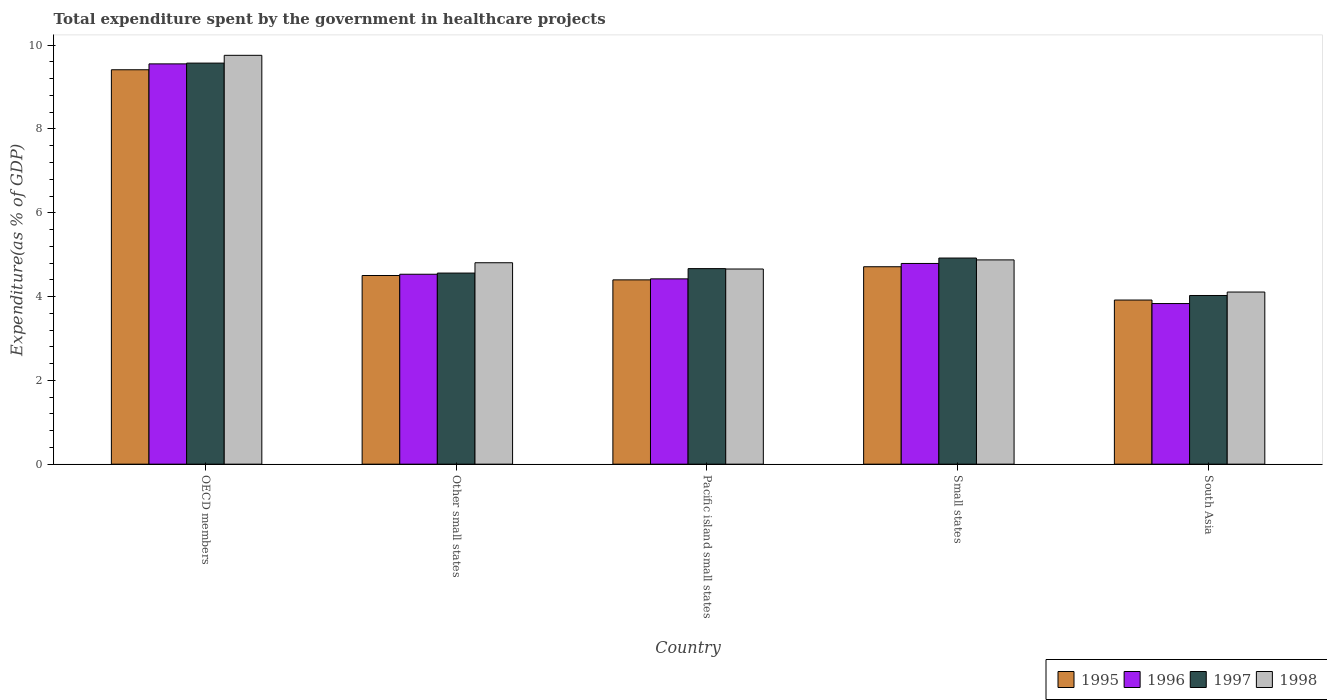How many different coloured bars are there?
Offer a very short reply. 4. How many groups of bars are there?
Your answer should be compact. 5. Are the number of bars on each tick of the X-axis equal?
Your answer should be very brief. Yes. How many bars are there on the 5th tick from the right?
Offer a very short reply. 4. What is the label of the 4th group of bars from the left?
Your answer should be compact. Small states. In how many cases, is the number of bars for a given country not equal to the number of legend labels?
Ensure brevity in your answer.  0. What is the total expenditure spent by the government in healthcare projects in 1998 in Pacific island small states?
Keep it short and to the point. 4.66. Across all countries, what is the maximum total expenditure spent by the government in healthcare projects in 1995?
Provide a succinct answer. 9.41. Across all countries, what is the minimum total expenditure spent by the government in healthcare projects in 1995?
Offer a very short reply. 3.92. In which country was the total expenditure spent by the government in healthcare projects in 1995 maximum?
Offer a terse response. OECD members. What is the total total expenditure spent by the government in healthcare projects in 1998 in the graph?
Offer a very short reply. 28.21. What is the difference between the total expenditure spent by the government in healthcare projects in 1996 in Other small states and that in Pacific island small states?
Provide a succinct answer. 0.11. What is the difference between the total expenditure spent by the government in healthcare projects in 1996 in Other small states and the total expenditure spent by the government in healthcare projects in 1998 in OECD members?
Offer a terse response. -5.23. What is the average total expenditure spent by the government in healthcare projects in 1997 per country?
Offer a very short reply. 5.55. What is the difference between the total expenditure spent by the government in healthcare projects of/in 1997 and total expenditure spent by the government in healthcare projects of/in 1995 in South Asia?
Your response must be concise. 0.11. In how many countries, is the total expenditure spent by the government in healthcare projects in 1996 greater than 1.6 %?
Give a very brief answer. 5. What is the ratio of the total expenditure spent by the government in healthcare projects in 1997 in Pacific island small states to that in South Asia?
Your answer should be very brief. 1.16. What is the difference between the highest and the second highest total expenditure spent by the government in healthcare projects in 1998?
Provide a short and direct response. 4.88. What is the difference between the highest and the lowest total expenditure spent by the government in healthcare projects in 1996?
Ensure brevity in your answer.  5.72. Is the sum of the total expenditure spent by the government in healthcare projects in 1996 in OECD members and South Asia greater than the maximum total expenditure spent by the government in healthcare projects in 1995 across all countries?
Your answer should be very brief. Yes. Is it the case that in every country, the sum of the total expenditure spent by the government in healthcare projects in 1996 and total expenditure spent by the government in healthcare projects in 1997 is greater than the sum of total expenditure spent by the government in healthcare projects in 1998 and total expenditure spent by the government in healthcare projects in 1995?
Your response must be concise. No. What does the 4th bar from the left in Other small states represents?
Give a very brief answer. 1998. What does the 2nd bar from the right in OECD members represents?
Make the answer very short. 1997. How many bars are there?
Keep it short and to the point. 20. Are all the bars in the graph horizontal?
Your answer should be very brief. No. Does the graph contain grids?
Your answer should be very brief. No. How many legend labels are there?
Provide a succinct answer. 4. What is the title of the graph?
Your response must be concise. Total expenditure spent by the government in healthcare projects. Does "1971" appear as one of the legend labels in the graph?
Your answer should be very brief. No. What is the label or title of the Y-axis?
Offer a very short reply. Expenditure(as % of GDP). What is the Expenditure(as % of GDP) of 1995 in OECD members?
Your answer should be very brief. 9.41. What is the Expenditure(as % of GDP) in 1996 in OECD members?
Provide a succinct answer. 9.55. What is the Expenditure(as % of GDP) in 1997 in OECD members?
Provide a short and direct response. 9.57. What is the Expenditure(as % of GDP) in 1998 in OECD members?
Provide a succinct answer. 9.76. What is the Expenditure(as % of GDP) in 1995 in Other small states?
Offer a terse response. 4.5. What is the Expenditure(as % of GDP) of 1996 in Other small states?
Keep it short and to the point. 4.53. What is the Expenditure(as % of GDP) in 1997 in Other small states?
Offer a very short reply. 4.56. What is the Expenditure(as % of GDP) of 1998 in Other small states?
Ensure brevity in your answer.  4.81. What is the Expenditure(as % of GDP) of 1995 in Pacific island small states?
Give a very brief answer. 4.4. What is the Expenditure(as % of GDP) of 1996 in Pacific island small states?
Offer a very short reply. 4.42. What is the Expenditure(as % of GDP) in 1997 in Pacific island small states?
Your answer should be compact. 4.67. What is the Expenditure(as % of GDP) of 1998 in Pacific island small states?
Provide a short and direct response. 4.66. What is the Expenditure(as % of GDP) in 1995 in Small states?
Provide a succinct answer. 4.71. What is the Expenditure(as % of GDP) of 1996 in Small states?
Your response must be concise. 4.79. What is the Expenditure(as % of GDP) in 1997 in Small states?
Your answer should be very brief. 4.92. What is the Expenditure(as % of GDP) in 1998 in Small states?
Offer a terse response. 4.88. What is the Expenditure(as % of GDP) in 1995 in South Asia?
Provide a succinct answer. 3.92. What is the Expenditure(as % of GDP) of 1996 in South Asia?
Make the answer very short. 3.83. What is the Expenditure(as % of GDP) in 1997 in South Asia?
Give a very brief answer. 4.03. What is the Expenditure(as % of GDP) of 1998 in South Asia?
Ensure brevity in your answer.  4.11. Across all countries, what is the maximum Expenditure(as % of GDP) in 1995?
Offer a terse response. 9.41. Across all countries, what is the maximum Expenditure(as % of GDP) in 1996?
Offer a very short reply. 9.55. Across all countries, what is the maximum Expenditure(as % of GDP) of 1997?
Keep it short and to the point. 9.57. Across all countries, what is the maximum Expenditure(as % of GDP) in 1998?
Offer a terse response. 9.76. Across all countries, what is the minimum Expenditure(as % of GDP) in 1995?
Give a very brief answer. 3.92. Across all countries, what is the minimum Expenditure(as % of GDP) of 1996?
Give a very brief answer. 3.83. Across all countries, what is the minimum Expenditure(as % of GDP) in 1997?
Ensure brevity in your answer.  4.03. Across all countries, what is the minimum Expenditure(as % of GDP) in 1998?
Ensure brevity in your answer.  4.11. What is the total Expenditure(as % of GDP) of 1995 in the graph?
Offer a very short reply. 26.94. What is the total Expenditure(as % of GDP) in 1996 in the graph?
Your answer should be compact. 27.13. What is the total Expenditure(as % of GDP) of 1997 in the graph?
Provide a succinct answer. 27.75. What is the total Expenditure(as % of GDP) in 1998 in the graph?
Offer a very short reply. 28.21. What is the difference between the Expenditure(as % of GDP) of 1995 in OECD members and that in Other small states?
Make the answer very short. 4.91. What is the difference between the Expenditure(as % of GDP) in 1996 in OECD members and that in Other small states?
Your response must be concise. 5.02. What is the difference between the Expenditure(as % of GDP) of 1997 in OECD members and that in Other small states?
Give a very brief answer. 5.01. What is the difference between the Expenditure(as % of GDP) of 1998 in OECD members and that in Other small states?
Your answer should be very brief. 4.95. What is the difference between the Expenditure(as % of GDP) of 1995 in OECD members and that in Pacific island small states?
Ensure brevity in your answer.  5.01. What is the difference between the Expenditure(as % of GDP) in 1996 in OECD members and that in Pacific island small states?
Make the answer very short. 5.13. What is the difference between the Expenditure(as % of GDP) of 1997 in OECD members and that in Pacific island small states?
Provide a short and direct response. 4.91. What is the difference between the Expenditure(as % of GDP) of 1998 in OECD members and that in Pacific island small states?
Offer a terse response. 5.1. What is the difference between the Expenditure(as % of GDP) of 1995 in OECD members and that in Small states?
Provide a succinct answer. 4.7. What is the difference between the Expenditure(as % of GDP) of 1996 in OECD members and that in Small states?
Your response must be concise. 4.76. What is the difference between the Expenditure(as % of GDP) in 1997 in OECD members and that in Small states?
Your answer should be compact. 4.65. What is the difference between the Expenditure(as % of GDP) in 1998 in OECD members and that in Small states?
Give a very brief answer. 4.88. What is the difference between the Expenditure(as % of GDP) of 1995 in OECD members and that in South Asia?
Your answer should be very brief. 5.5. What is the difference between the Expenditure(as % of GDP) in 1996 in OECD members and that in South Asia?
Provide a succinct answer. 5.72. What is the difference between the Expenditure(as % of GDP) in 1997 in OECD members and that in South Asia?
Offer a terse response. 5.55. What is the difference between the Expenditure(as % of GDP) of 1998 in OECD members and that in South Asia?
Give a very brief answer. 5.65. What is the difference between the Expenditure(as % of GDP) in 1995 in Other small states and that in Pacific island small states?
Your response must be concise. 0.1. What is the difference between the Expenditure(as % of GDP) in 1996 in Other small states and that in Pacific island small states?
Give a very brief answer. 0.11. What is the difference between the Expenditure(as % of GDP) of 1997 in Other small states and that in Pacific island small states?
Provide a succinct answer. -0.11. What is the difference between the Expenditure(as % of GDP) of 1998 in Other small states and that in Pacific island small states?
Give a very brief answer. 0.15. What is the difference between the Expenditure(as % of GDP) in 1995 in Other small states and that in Small states?
Provide a short and direct response. -0.21. What is the difference between the Expenditure(as % of GDP) of 1996 in Other small states and that in Small states?
Offer a very short reply. -0.26. What is the difference between the Expenditure(as % of GDP) of 1997 in Other small states and that in Small states?
Provide a succinct answer. -0.36. What is the difference between the Expenditure(as % of GDP) of 1998 in Other small states and that in Small states?
Keep it short and to the point. -0.07. What is the difference between the Expenditure(as % of GDP) in 1995 in Other small states and that in South Asia?
Offer a terse response. 0.59. What is the difference between the Expenditure(as % of GDP) of 1996 in Other small states and that in South Asia?
Give a very brief answer. 0.7. What is the difference between the Expenditure(as % of GDP) in 1997 in Other small states and that in South Asia?
Keep it short and to the point. 0.54. What is the difference between the Expenditure(as % of GDP) of 1998 in Other small states and that in South Asia?
Give a very brief answer. 0.7. What is the difference between the Expenditure(as % of GDP) in 1995 in Pacific island small states and that in Small states?
Give a very brief answer. -0.31. What is the difference between the Expenditure(as % of GDP) of 1996 in Pacific island small states and that in Small states?
Your answer should be very brief. -0.37. What is the difference between the Expenditure(as % of GDP) in 1997 in Pacific island small states and that in Small states?
Your answer should be compact. -0.25. What is the difference between the Expenditure(as % of GDP) of 1998 in Pacific island small states and that in Small states?
Your answer should be compact. -0.22. What is the difference between the Expenditure(as % of GDP) of 1995 in Pacific island small states and that in South Asia?
Provide a succinct answer. 0.48. What is the difference between the Expenditure(as % of GDP) of 1996 in Pacific island small states and that in South Asia?
Provide a succinct answer. 0.59. What is the difference between the Expenditure(as % of GDP) in 1997 in Pacific island small states and that in South Asia?
Give a very brief answer. 0.64. What is the difference between the Expenditure(as % of GDP) in 1998 in Pacific island small states and that in South Asia?
Provide a succinct answer. 0.55. What is the difference between the Expenditure(as % of GDP) of 1995 in Small states and that in South Asia?
Offer a very short reply. 0.79. What is the difference between the Expenditure(as % of GDP) of 1997 in Small states and that in South Asia?
Your answer should be compact. 0.89. What is the difference between the Expenditure(as % of GDP) in 1998 in Small states and that in South Asia?
Your answer should be compact. 0.77. What is the difference between the Expenditure(as % of GDP) of 1995 in OECD members and the Expenditure(as % of GDP) of 1996 in Other small states?
Offer a terse response. 4.88. What is the difference between the Expenditure(as % of GDP) of 1995 in OECD members and the Expenditure(as % of GDP) of 1997 in Other small states?
Offer a very short reply. 4.85. What is the difference between the Expenditure(as % of GDP) of 1995 in OECD members and the Expenditure(as % of GDP) of 1998 in Other small states?
Your answer should be very brief. 4.61. What is the difference between the Expenditure(as % of GDP) of 1996 in OECD members and the Expenditure(as % of GDP) of 1997 in Other small states?
Your answer should be very brief. 4.99. What is the difference between the Expenditure(as % of GDP) of 1996 in OECD members and the Expenditure(as % of GDP) of 1998 in Other small states?
Your answer should be compact. 4.75. What is the difference between the Expenditure(as % of GDP) of 1997 in OECD members and the Expenditure(as % of GDP) of 1998 in Other small states?
Ensure brevity in your answer.  4.77. What is the difference between the Expenditure(as % of GDP) in 1995 in OECD members and the Expenditure(as % of GDP) in 1996 in Pacific island small states?
Your response must be concise. 4.99. What is the difference between the Expenditure(as % of GDP) in 1995 in OECD members and the Expenditure(as % of GDP) in 1997 in Pacific island small states?
Offer a very short reply. 4.75. What is the difference between the Expenditure(as % of GDP) of 1995 in OECD members and the Expenditure(as % of GDP) of 1998 in Pacific island small states?
Your answer should be very brief. 4.76. What is the difference between the Expenditure(as % of GDP) in 1996 in OECD members and the Expenditure(as % of GDP) in 1997 in Pacific island small states?
Your response must be concise. 4.89. What is the difference between the Expenditure(as % of GDP) in 1996 in OECD members and the Expenditure(as % of GDP) in 1998 in Pacific island small states?
Your response must be concise. 4.9. What is the difference between the Expenditure(as % of GDP) of 1997 in OECD members and the Expenditure(as % of GDP) of 1998 in Pacific island small states?
Provide a succinct answer. 4.91. What is the difference between the Expenditure(as % of GDP) in 1995 in OECD members and the Expenditure(as % of GDP) in 1996 in Small states?
Keep it short and to the point. 4.62. What is the difference between the Expenditure(as % of GDP) in 1995 in OECD members and the Expenditure(as % of GDP) in 1997 in Small states?
Provide a succinct answer. 4.49. What is the difference between the Expenditure(as % of GDP) in 1995 in OECD members and the Expenditure(as % of GDP) in 1998 in Small states?
Give a very brief answer. 4.54. What is the difference between the Expenditure(as % of GDP) in 1996 in OECD members and the Expenditure(as % of GDP) in 1997 in Small states?
Provide a succinct answer. 4.63. What is the difference between the Expenditure(as % of GDP) of 1996 in OECD members and the Expenditure(as % of GDP) of 1998 in Small states?
Your answer should be compact. 4.68. What is the difference between the Expenditure(as % of GDP) of 1997 in OECD members and the Expenditure(as % of GDP) of 1998 in Small states?
Keep it short and to the point. 4.7. What is the difference between the Expenditure(as % of GDP) in 1995 in OECD members and the Expenditure(as % of GDP) in 1996 in South Asia?
Your response must be concise. 5.58. What is the difference between the Expenditure(as % of GDP) of 1995 in OECD members and the Expenditure(as % of GDP) of 1997 in South Asia?
Your answer should be compact. 5.39. What is the difference between the Expenditure(as % of GDP) in 1995 in OECD members and the Expenditure(as % of GDP) in 1998 in South Asia?
Offer a very short reply. 5.31. What is the difference between the Expenditure(as % of GDP) in 1996 in OECD members and the Expenditure(as % of GDP) in 1997 in South Asia?
Ensure brevity in your answer.  5.53. What is the difference between the Expenditure(as % of GDP) of 1996 in OECD members and the Expenditure(as % of GDP) of 1998 in South Asia?
Your response must be concise. 5.45. What is the difference between the Expenditure(as % of GDP) in 1997 in OECD members and the Expenditure(as % of GDP) in 1998 in South Asia?
Your answer should be compact. 5.46. What is the difference between the Expenditure(as % of GDP) of 1995 in Other small states and the Expenditure(as % of GDP) of 1996 in Pacific island small states?
Your answer should be very brief. 0.08. What is the difference between the Expenditure(as % of GDP) of 1995 in Other small states and the Expenditure(as % of GDP) of 1997 in Pacific island small states?
Your answer should be very brief. -0.16. What is the difference between the Expenditure(as % of GDP) of 1995 in Other small states and the Expenditure(as % of GDP) of 1998 in Pacific island small states?
Your answer should be compact. -0.16. What is the difference between the Expenditure(as % of GDP) in 1996 in Other small states and the Expenditure(as % of GDP) in 1997 in Pacific island small states?
Ensure brevity in your answer.  -0.13. What is the difference between the Expenditure(as % of GDP) in 1996 in Other small states and the Expenditure(as % of GDP) in 1998 in Pacific island small states?
Your answer should be compact. -0.12. What is the difference between the Expenditure(as % of GDP) of 1997 in Other small states and the Expenditure(as % of GDP) of 1998 in Pacific island small states?
Ensure brevity in your answer.  -0.1. What is the difference between the Expenditure(as % of GDP) in 1995 in Other small states and the Expenditure(as % of GDP) in 1996 in Small states?
Your response must be concise. -0.29. What is the difference between the Expenditure(as % of GDP) of 1995 in Other small states and the Expenditure(as % of GDP) of 1997 in Small states?
Your answer should be very brief. -0.42. What is the difference between the Expenditure(as % of GDP) of 1995 in Other small states and the Expenditure(as % of GDP) of 1998 in Small states?
Give a very brief answer. -0.37. What is the difference between the Expenditure(as % of GDP) of 1996 in Other small states and the Expenditure(as % of GDP) of 1997 in Small states?
Give a very brief answer. -0.39. What is the difference between the Expenditure(as % of GDP) in 1996 in Other small states and the Expenditure(as % of GDP) in 1998 in Small states?
Provide a succinct answer. -0.34. What is the difference between the Expenditure(as % of GDP) of 1997 in Other small states and the Expenditure(as % of GDP) of 1998 in Small states?
Make the answer very short. -0.31. What is the difference between the Expenditure(as % of GDP) of 1995 in Other small states and the Expenditure(as % of GDP) of 1996 in South Asia?
Make the answer very short. 0.67. What is the difference between the Expenditure(as % of GDP) in 1995 in Other small states and the Expenditure(as % of GDP) in 1997 in South Asia?
Your answer should be very brief. 0.48. What is the difference between the Expenditure(as % of GDP) of 1995 in Other small states and the Expenditure(as % of GDP) of 1998 in South Asia?
Provide a succinct answer. 0.39. What is the difference between the Expenditure(as % of GDP) in 1996 in Other small states and the Expenditure(as % of GDP) in 1997 in South Asia?
Your answer should be very brief. 0.51. What is the difference between the Expenditure(as % of GDP) in 1996 in Other small states and the Expenditure(as % of GDP) in 1998 in South Asia?
Keep it short and to the point. 0.42. What is the difference between the Expenditure(as % of GDP) in 1997 in Other small states and the Expenditure(as % of GDP) in 1998 in South Asia?
Ensure brevity in your answer.  0.45. What is the difference between the Expenditure(as % of GDP) of 1995 in Pacific island small states and the Expenditure(as % of GDP) of 1996 in Small states?
Provide a succinct answer. -0.39. What is the difference between the Expenditure(as % of GDP) of 1995 in Pacific island small states and the Expenditure(as % of GDP) of 1997 in Small states?
Your answer should be compact. -0.52. What is the difference between the Expenditure(as % of GDP) in 1995 in Pacific island small states and the Expenditure(as % of GDP) in 1998 in Small states?
Make the answer very short. -0.48. What is the difference between the Expenditure(as % of GDP) in 1996 in Pacific island small states and the Expenditure(as % of GDP) in 1997 in Small states?
Your answer should be very brief. -0.5. What is the difference between the Expenditure(as % of GDP) of 1996 in Pacific island small states and the Expenditure(as % of GDP) of 1998 in Small states?
Offer a very short reply. -0.45. What is the difference between the Expenditure(as % of GDP) in 1997 in Pacific island small states and the Expenditure(as % of GDP) in 1998 in Small states?
Keep it short and to the point. -0.21. What is the difference between the Expenditure(as % of GDP) of 1995 in Pacific island small states and the Expenditure(as % of GDP) of 1996 in South Asia?
Provide a succinct answer. 0.57. What is the difference between the Expenditure(as % of GDP) of 1995 in Pacific island small states and the Expenditure(as % of GDP) of 1997 in South Asia?
Ensure brevity in your answer.  0.37. What is the difference between the Expenditure(as % of GDP) in 1995 in Pacific island small states and the Expenditure(as % of GDP) in 1998 in South Asia?
Ensure brevity in your answer.  0.29. What is the difference between the Expenditure(as % of GDP) in 1996 in Pacific island small states and the Expenditure(as % of GDP) in 1997 in South Asia?
Ensure brevity in your answer.  0.4. What is the difference between the Expenditure(as % of GDP) of 1996 in Pacific island small states and the Expenditure(as % of GDP) of 1998 in South Asia?
Keep it short and to the point. 0.31. What is the difference between the Expenditure(as % of GDP) in 1997 in Pacific island small states and the Expenditure(as % of GDP) in 1998 in South Asia?
Keep it short and to the point. 0.56. What is the difference between the Expenditure(as % of GDP) of 1995 in Small states and the Expenditure(as % of GDP) of 1996 in South Asia?
Make the answer very short. 0.88. What is the difference between the Expenditure(as % of GDP) in 1995 in Small states and the Expenditure(as % of GDP) in 1997 in South Asia?
Your answer should be compact. 0.69. What is the difference between the Expenditure(as % of GDP) of 1995 in Small states and the Expenditure(as % of GDP) of 1998 in South Asia?
Provide a short and direct response. 0.6. What is the difference between the Expenditure(as % of GDP) of 1996 in Small states and the Expenditure(as % of GDP) of 1997 in South Asia?
Your answer should be compact. 0.76. What is the difference between the Expenditure(as % of GDP) of 1996 in Small states and the Expenditure(as % of GDP) of 1998 in South Asia?
Your answer should be compact. 0.68. What is the difference between the Expenditure(as % of GDP) of 1997 in Small states and the Expenditure(as % of GDP) of 1998 in South Asia?
Give a very brief answer. 0.81. What is the average Expenditure(as % of GDP) in 1995 per country?
Keep it short and to the point. 5.39. What is the average Expenditure(as % of GDP) of 1996 per country?
Your answer should be very brief. 5.43. What is the average Expenditure(as % of GDP) in 1997 per country?
Make the answer very short. 5.55. What is the average Expenditure(as % of GDP) of 1998 per country?
Your answer should be very brief. 5.64. What is the difference between the Expenditure(as % of GDP) in 1995 and Expenditure(as % of GDP) in 1996 in OECD members?
Ensure brevity in your answer.  -0.14. What is the difference between the Expenditure(as % of GDP) of 1995 and Expenditure(as % of GDP) of 1997 in OECD members?
Ensure brevity in your answer.  -0.16. What is the difference between the Expenditure(as % of GDP) in 1995 and Expenditure(as % of GDP) in 1998 in OECD members?
Give a very brief answer. -0.34. What is the difference between the Expenditure(as % of GDP) in 1996 and Expenditure(as % of GDP) in 1997 in OECD members?
Offer a terse response. -0.02. What is the difference between the Expenditure(as % of GDP) in 1996 and Expenditure(as % of GDP) in 1998 in OECD members?
Provide a succinct answer. -0.2. What is the difference between the Expenditure(as % of GDP) of 1997 and Expenditure(as % of GDP) of 1998 in OECD members?
Ensure brevity in your answer.  -0.19. What is the difference between the Expenditure(as % of GDP) of 1995 and Expenditure(as % of GDP) of 1996 in Other small states?
Keep it short and to the point. -0.03. What is the difference between the Expenditure(as % of GDP) in 1995 and Expenditure(as % of GDP) in 1997 in Other small states?
Your answer should be compact. -0.06. What is the difference between the Expenditure(as % of GDP) in 1995 and Expenditure(as % of GDP) in 1998 in Other small states?
Keep it short and to the point. -0.3. What is the difference between the Expenditure(as % of GDP) in 1996 and Expenditure(as % of GDP) in 1997 in Other small states?
Give a very brief answer. -0.03. What is the difference between the Expenditure(as % of GDP) in 1996 and Expenditure(as % of GDP) in 1998 in Other small states?
Your answer should be very brief. -0.27. What is the difference between the Expenditure(as % of GDP) of 1997 and Expenditure(as % of GDP) of 1998 in Other small states?
Give a very brief answer. -0.25. What is the difference between the Expenditure(as % of GDP) of 1995 and Expenditure(as % of GDP) of 1996 in Pacific island small states?
Ensure brevity in your answer.  -0.02. What is the difference between the Expenditure(as % of GDP) of 1995 and Expenditure(as % of GDP) of 1997 in Pacific island small states?
Make the answer very short. -0.27. What is the difference between the Expenditure(as % of GDP) of 1995 and Expenditure(as % of GDP) of 1998 in Pacific island small states?
Your answer should be compact. -0.26. What is the difference between the Expenditure(as % of GDP) in 1996 and Expenditure(as % of GDP) in 1997 in Pacific island small states?
Provide a short and direct response. -0.24. What is the difference between the Expenditure(as % of GDP) of 1996 and Expenditure(as % of GDP) of 1998 in Pacific island small states?
Offer a terse response. -0.24. What is the difference between the Expenditure(as % of GDP) of 1997 and Expenditure(as % of GDP) of 1998 in Pacific island small states?
Your answer should be compact. 0.01. What is the difference between the Expenditure(as % of GDP) in 1995 and Expenditure(as % of GDP) in 1996 in Small states?
Offer a very short reply. -0.08. What is the difference between the Expenditure(as % of GDP) of 1995 and Expenditure(as % of GDP) of 1997 in Small states?
Offer a very short reply. -0.21. What is the difference between the Expenditure(as % of GDP) in 1995 and Expenditure(as % of GDP) in 1998 in Small states?
Provide a short and direct response. -0.16. What is the difference between the Expenditure(as % of GDP) in 1996 and Expenditure(as % of GDP) in 1997 in Small states?
Keep it short and to the point. -0.13. What is the difference between the Expenditure(as % of GDP) in 1996 and Expenditure(as % of GDP) in 1998 in Small states?
Ensure brevity in your answer.  -0.09. What is the difference between the Expenditure(as % of GDP) in 1997 and Expenditure(as % of GDP) in 1998 in Small states?
Offer a terse response. 0.04. What is the difference between the Expenditure(as % of GDP) in 1995 and Expenditure(as % of GDP) in 1996 in South Asia?
Your answer should be very brief. 0.08. What is the difference between the Expenditure(as % of GDP) of 1995 and Expenditure(as % of GDP) of 1997 in South Asia?
Your response must be concise. -0.11. What is the difference between the Expenditure(as % of GDP) in 1995 and Expenditure(as % of GDP) in 1998 in South Asia?
Make the answer very short. -0.19. What is the difference between the Expenditure(as % of GDP) of 1996 and Expenditure(as % of GDP) of 1997 in South Asia?
Offer a terse response. -0.19. What is the difference between the Expenditure(as % of GDP) of 1996 and Expenditure(as % of GDP) of 1998 in South Asia?
Your response must be concise. -0.27. What is the difference between the Expenditure(as % of GDP) of 1997 and Expenditure(as % of GDP) of 1998 in South Asia?
Keep it short and to the point. -0.08. What is the ratio of the Expenditure(as % of GDP) in 1995 in OECD members to that in Other small states?
Give a very brief answer. 2.09. What is the ratio of the Expenditure(as % of GDP) of 1996 in OECD members to that in Other small states?
Provide a succinct answer. 2.11. What is the ratio of the Expenditure(as % of GDP) in 1997 in OECD members to that in Other small states?
Your answer should be very brief. 2.1. What is the ratio of the Expenditure(as % of GDP) in 1998 in OECD members to that in Other small states?
Provide a short and direct response. 2.03. What is the ratio of the Expenditure(as % of GDP) in 1995 in OECD members to that in Pacific island small states?
Ensure brevity in your answer.  2.14. What is the ratio of the Expenditure(as % of GDP) in 1996 in OECD members to that in Pacific island small states?
Offer a terse response. 2.16. What is the ratio of the Expenditure(as % of GDP) in 1997 in OECD members to that in Pacific island small states?
Ensure brevity in your answer.  2.05. What is the ratio of the Expenditure(as % of GDP) of 1998 in OECD members to that in Pacific island small states?
Your answer should be very brief. 2.1. What is the ratio of the Expenditure(as % of GDP) of 1995 in OECD members to that in Small states?
Give a very brief answer. 2. What is the ratio of the Expenditure(as % of GDP) of 1996 in OECD members to that in Small states?
Give a very brief answer. 1.99. What is the ratio of the Expenditure(as % of GDP) in 1997 in OECD members to that in Small states?
Provide a succinct answer. 1.95. What is the ratio of the Expenditure(as % of GDP) of 1998 in OECD members to that in Small states?
Make the answer very short. 2. What is the ratio of the Expenditure(as % of GDP) of 1995 in OECD members to that in South Asia?
Provide a succinct answer. 2.4. What is the ratio of the Expenditure(as % of GDP) in 1996 in OECD members to that in South Asia?
Give a very brief answer. 2.49. What is the ratio of the Expenditure(as % of GDP) of 1997 in OECD members to that in South Asia?
Ensure brevity in your answer.  2.38. What is the ratio of the Expenditure(as % of GDP) in 1998 in OECD members to that in South Asia?
Keep it short and to the point. 2.38. What is the ratio of the Expenditure(as % of GDP) in 1995 in Other small states to that in Pacific island small states?
Provide a short and direct response. 1.02. What is the ratio of the Expenditure(as % of GDP) in 1996 in Other small states to that in Pacific island small states?
Provide a succinct answer. 1.02. What is the ratio of the Expenditure(as % of GDP) of 1997 in Other small states to that in Pacific island small states?
Give a very brief answer. 0.98. What is the ratio of the Expenditure(as % of GDP) of 1998 in Other small states to that in Pacific island small states?
Your response must be concise. 1.03. What is the ratio of the Expenditure(as % of GDP) of 1995 in Other small states to that in Small states?
Make the answer very short. 0.96. What is the ratio of the Expenditure(as % of GDP) of 1996 in Other small states to that in Small states?
Make the answer very short. 0.95. What is the ratio of the Expenditure(as % of GDP) in 1997 in Other small states to that in Small states?
Give a very brief answer. 0.93. What is the ratio of the Expenditure(as % of GDP) in 1998 in Other small states to that in Small states?
Give a very brief answer. 0.99. What is the ratio of the Expenditure(as % of GDP) of 1995 in Other small states to that in South Asia?
Offer a very short reply. 1.15. What is the ratio of the Expenditure(as % of GDP) of 1996 in Other small states to that in South Asia?
Provide a succinct answer. 1.18. What is the ratio of the Expenditure(as % of GDP) of 1997 in Other small states to that in South Asia?
Provide a short and direct response. 1.13. What is the ratio of the Expenditure(as % of GDP) of 1998 in Other small states to that in South Asia?
Keep it short and to the point. 1.17. What is the ratio of the Expenditure(as % of GDP) in 1995 in Pacific island small states to that in Small states?
Offer a very short reply. 0.93. What is the ratio of the Expenditure(as % of GDP) in 1996 in Pacific island small states to that in Small states?
Your answer should be compact. 0.92. What is the ratio of the Expenditure(as % of GDP) of 1997 in Pacific island small states to that in Small states?
Your answer should be very brief. 0.95. What is the ratio of the Expenditure(as % of GDP) of 1998 in Pacific island small states to that in Small states?
Your answer should be very brief. 0.96. What is the ratio of the Expenditure(as % of GDP) of 1995 in Pacific island small states to that in South Asia?
Your response must be concise. 1.12. What is the ratio of the Expenditure(as % of GDP) of 1996 in Pacific island small states to that in South Asia?
Make the answer very short. 1.15. What is the ratio of the Expenditure(as % of GDP) of 1997 in Pacific island small states to that in South Asia?
Make the answer very short. 1.16. What is the ratio of the Expenditure(as % of GDP) in 1998 in Pacific island small states to that in South Asia?
Offer a terse response. 1.13. What is the ratio of the Expenditure(as % of GDP) of 1995 in Small states to that in South Asia?
Your answer should be compact. 1.2. What is the ratio of the Expenditure(as % of GDP) of 1996 in Small states to that in South Asia?
Provide a succinct answer. 1.25. What is the ratio of the Expenditure(as % of GDP) of 1997 in Small states to that in South Asia?
Offer a terse response. 1.22. What is the ratio of the Expenditure(as % of GDP) in 1998 in Small states to that in South Asia?
Provide a succinct answer. 1.19. What is the difference between the highest and the second highest Expenditure(as % of GDP) in 1995?
Keep it short and to the point. 4.7. What is the difference between the highest and the second highest Expenditure(as % of GDP) of 1996?
Provide a short and direct response. 4.76. What is the difference between the highest and the second highest Expenditure(as % of GDP) of 1997?
Your answer should be compact. 4.65. What is the difference between the highest and the second highest Expenditure(as % of GDP) in 1998?
Keep it short and to the point. 4.88. What is the difference between the highest and the lowest Expenditure(as % of GDP) of 1995?
Provide a succinct answer. 5.5. What is the difference between the highest and the lowest Expenditure(as % of GDP) of 1996?
Give a very brief answer. 5.72. What is the difference between the highest and the lowest Expenditure(as % of GDP) of 1997?
Make the answer very short. 5.55. What is the difference between the highest and the lowest Expenditure(as % of GDP) in 1998?
Make the answer very short. 5.65. 